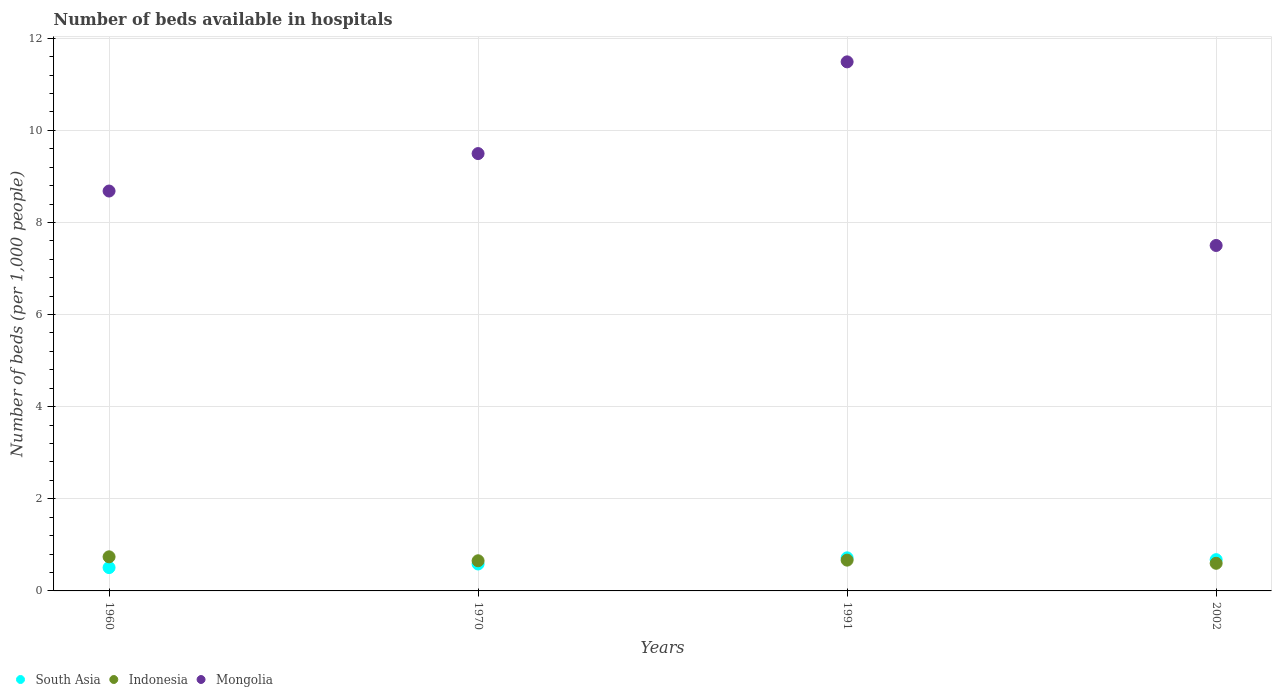How many different coloured dotlines are there?
Provide a short and direct response. 3. Is the number of dotlines equal to the number of legend labels?
Your answer should be compact. Yes. What is the number of beds in the hospiatls of in South Asia in 1970?
Make the answer very short. 0.58. Across all years, what is the maximum number of beds in the hospiatls of in South Asia?
Ensure brevity in your answer.  0.72. Across all years, what is the minimum number of beds in the hospiatls of in Indonesia?
Provide a succinct answer. 0.6. In which year was the number of beds in the hospiatls of in South Asia minimum?
Provide a short and direct response. 1960. What is the total number of beds in the hospiatls of in Mongolia in the graph?
Your response must be concise. 37.16. What is the difference between the number of beds in the hospiatls of in South Asia in 1960 and that in 1991?
Keep it short and to the point. -0.21. What is the difference between the number of beds in the hospiatls of in South Asia in 1991 and the number of beds in the hospiatls of in Mongolia in 1970?
Ensure brevity in your answer.  -8.78. What is the average number of beds in the hospiatls of in Mongolia per year?
Your response must be concise. 9.29. In the year 1970, what is the difference between the number of beds in the hospiatls of in Mongolia and number of beds in the hospiatls of in South Asia?
Keep it short and to the point. 8.91. In how many years, is the number of beds in the hospiatls of in Mongolia greater than 6?
Provide a short and direct response. 4. What is the ratio of the number of beds in the hospiatls of in Mongolia in 1960 to that in 2002?
Provide a succinct answer. 1.16. Is the number of beds in the hospiatls of in Indonesia in 1970 less than that in 1991?
Your answer should be compact. Yes. What is the difference between the highest and the second highest number of beds in the hospiatls of in Indonesia?
Provide a short and direct response. 0.07. What is the difference between the highest and the lowest number of beds in the hospiatls of in Mongolia?
Provide a short and direct response. 3.99. Is the sum of the number of beds in the hospiatls of in Mongolia in 1970 and 1991 greater than the maximum number of beds in the hospiatls of in Indonesia across all years?
Give a very brief answer. Yes. How many dotlines are there?
Offer a very short reply. 3. How many years are there in the graph?
Give a very brief answer. 4. Are the values on the major ticks of Y-axis written in scientific E-notation?
Offer a terse response. No. Does the graph contain any zero values?
Make the answer very short. No. Does the graph contain grids?
Keep it short and to the point. Yes. Where does the legend appear in the graph?
Your answer should be very brief. Bottom left. How many legend labels are there?
Your answer should be compact. 3. How are the legend labels stacked?
Ensure brevity in your answer.  Horizontal. What is the title of the graph?
Provide a succinct answer. Number of beds available in hospitals. Does "Cameroon" appear as one of the legend labels in the graph?
Give a very brief answer. No. What is the label or title of the Y-axis?
Keep it short and to the point. Number of beds (per 1,0 people). What is the Number of beds (per 1,000 people) in South Asia in 1960?
Offer a very short reply. 0.51. What is the Number of beds (per 1,000 people) in Indonesia in 1960?
Offer a very short reply. 0.74. What is the Number of beds (per 1,000 people) of Mongolia in 1960?
Give a very brief answer. 8.68. What is the Number of beds (per 1,000 people) in South Asia in 1970?
Your response must be concise. 0.58. What is the Number of beds (per 1,000 people) of Indonesia in 1970?
Your answer should be very brief. 0.65. What is the Number of beds (per 1,000 people) of Mongolia in 1970?
Your answer should be compact. 9.5. What is the Number of beds (per 1,000 people) of South Asia in 1991?
Make the answer very short. 0.72. What is the Number of beds (per 1,000 people) of Indonesia in 1991?
Provide a succinct answer. 0.67. What is the Number of beds (per 1,000 people) in Mongolia in 1991?
Provide a short and direct response. 11.49. What is the Number of beds (per 1,000 people) of South Asia in 2002?
Your answer should be compact. 0.68. Across all years, what is the maximum Number of beds (per 1,000 people) in South Asia?
Your response must be concise. 0.72. Across all years, what is the maximum Number of beds (per 1,000 people) of Indonesia?
Offer a terse response. 0.74. Across all years, what is the maximum Number of beds (per 1,000 people) of Mongolia?
Your answer should be compact. 11.49. Across all years, what is the minimum Number of beds (per 1,000 people) of South Asia?
Offer a very short reply. 0.51. What is the total Number of beds (per 1,000 people) in South Asia in the graph?
Ensure brevity in your answer.  2.49. What is the total Number of beds (per 1,000 people) in Indonesia in the graph?
Give a very brief answer. 2.66. What is the total Number of beds (per 1,000 people) of Mongolia in the graph?
Ensure brevity in your answer.  37.16. What is the difference between the Number of beds (per 1,000 people) in South Asia in 1960 and that in 1970?
Provide a short and direct response. -0.08. What is the difference between the Number of beds (per 1,000 people) of Indonesia in 1960 and that in 1970?
Give a very brief answer. 0.09. What is the difference between the Number of beds (per 1,000 people) in Mongolia in 1960 and that in 1970?
Keep it short and to the point. -0.81. What is the difference between the Number of beds (per 1,000 people) in South Asia in 1960 and that in 1991?
Give a very brief answer. -0.21. What is the difference between the Number of beds (per 1,000 people) in Indonesia in 1960 and that in 1991?
Your response must be concise. 0.07. What is the difference between the Number of beds (per 1,000 people) of Mongolia in 1960 and that in 1991?
Offer a terse response. -2.8. What is the difference between the Number of beds (per 1,000 people) in South Asia in 1960 and that in 2002?
Make the answer very short. -0.17. What is the difference between the Number of beds (per 1,000 people) in Indonesia in 1960 and that in 2002?
Offer a terse response. 0.14. What is the difference between the Number of beds (per 1,000 people) in Mongolia in 1960 and that in 2002?
Provide a short and direct response. 1.18. What is the difference between the Number of beds (per 1,000 people) of South Asia in 1970 and that in 1991?
Your answer should be very brief. -0.13. What is the difference between the Number of beds (per 1,000 people) of Indonesia in 1970 and that in 1991?
Provide a succinct answer. -0.01. What is the difference between the Number of beds (per 1,000 people) in Mongolia in 1970 and that in 1991?
Offer a terse response. -1.99. What is the difference between the Number of beds (per 1,000 people) in South Asia in 1970 and that in 2002?
Make the answer very short. -0.09. What is the difference between the Number of beds (per 1,000 people) of Indonesia in 1970 and that in 2002?
Make the answer very short. 0.05. What is the difference between the Number of beds (per 1,000 people) in Mongolia in 1970 and that in 2002?
Provide a short and direct response. 2. What is the difference between the Number of beds (per 1,000 people) in South Asia in 1991 and that in 2002?
Provide a short and direct response. 0.04. What is the difference between the Number of beds (per 1,000 people) in Indonesia in 1991 and that in 2002?
Make the answer very short. 0.07. What is the difference between the Number of beds (per 1,000 people) in Mongolia in 1991 and that in 2002?
Ensure brevity in your answer.  3.99. What is the difference between the Number of beds (per 1,000 people) in South Asia in 1960 and the Number of beds (per 1,000 people) in Indonesia in 1970?
Provide a short and direct response. -0.15. What is the difference between the Number of beds (per 1,000 people) in South Asia in 1960 and the Number of beds (per 1,000 people) in Mongolia in 1970?
Ensure brevity in your answer.  -8.99. What is the difference between the Number of beds (per 1,000 people) in Indonesia in 1960 and the Number of beds (per 1,000 people) in Mongolia in 1970?
Your answer should be compact. -8.75. What is the difference between the Number of beds (per 1,000 people) in South Asia in 1960 and the Number of beds (per 1,000 people) in Indonesia in 1991?
Your answer should be very brief. -0.16. What is the difference between the Number of beds (per 1,000 people) of South Asia in 1960 and the Number of beds (per 1,000 people) of Mongolia in 1991?
Offer a very short reply. -10.98. What is the difference between the Number of beds (per 1,000 people) in Indonesia in 1960 and the Number of beds (per 1,000 people) in Mongolia in 1991?
Ensure brevity in your answer.  -10.75. What is the difference between the Number of beds (per 1,000 people) in South Asia in 1960 and the Number of beds (per 1,000 people) in Indonesia in 2002?
Ensure brevity in your answer.  -0.09. What is the difference between the Number of beds (per 1,000 people) of South Asia in 1960 and the Number of beds (per 1,000 people) of Mongolia in 2002?
Give a very brief answer. -6.99. What is the difference between the Number of beds (per 1,000 people) in Indonesia in 1960 and the Number of beds (per 1,000 people) in Mongolia in 2002?
Make the answer very short. -6.76. What is the difference between the Number of beds (per 1,000 people) of South Asia in 1970 and the Number of beds (per 1,000 people) of Indonesia in 1991?
Give a very brief answer. -0.08. What is the difference between the Number of beds (per 1,000 people) in South Asia in 1970 and the Number of beds (per 1,000 people) in Mongolia in 1991?
Offer a very short reply. -10.9. What is the difference between the Number of beds (per 1,000 people) in Indonesia in 1970 and the Number of beds (per 1,000 people) in Mongolia in 1991?
Make the answer very short. -10.83. What is the difference between the Number of beds (per 1,000 people) of South Asia in 1970 and the Number of beds (per 1,000 people) of Indonesia in 2002?
Your answer should be very brief. -0.02. What is the difference between the Number of beds (per 1,000 people) in South Asia in 1970 and the Number of beds (per 1,000 people) in Mongolia in 2002?
Your response must be concise. -6.92. What is the difference between the Number of beds (per 1,000 people) of Indonesia in 1970 and the Number of beds (per 1,000 people) of Mongolia in 2002?
Your answer should be very brief. -6.85. What is the difference between the Number of beds (per 1,000 people) in South Asia in 1991 and the Number of beds (per 1,000 people) in Indonesia in 2002?
Offer a terse response. 0.12. What is the difference between the Number of beds (per 1,000 people) of South Asia in 1991 and the Number of beds (per 1,000 people) of Mongolia in 2002?
Provide a succinct answer. -6.78. What is the difference between the Number of beds (per 1,000 people) of Indonesia in 1991 and the Number of beds (per 1,000 people) of Mongolia in 2002?
Ensure brevity in your answer.  -6.83. What is the average Number of beds (per 1,000 people) of South Asia per year?
Provide a short and direct response. 0.62. What is the average Number of beds (per 1,000 people) of Indonesia per year?
Make the answer very short. 0.67. What is the average Number of beds (per 1,000 people) of Mongolia per year?
Ensure brevity in your answer.  9.29. In the year 1960, what is the difference between the Number of beds (per 1,000 people) in South Asia and Number of beds (per 1,000 people) in Indonesia?
Offer a very short reply. -0.23. In the year 1960, what is the difference between the Number of beds (per 1,000 people) in South Asia and Number of beds (per 1,000 people) in Mongolia?
Offer a terse response. -8.18. In the year 1960, what is the difference between the Number of beds (per 1,000 people) of Indonesia and Number of beds (per 1,000 people) of Mongolia?
Offer a very short reply. -7.94. In the year 1970, what is the difference between the Number of beds (per 1,000 people) in South Asia and Number of beds (per 1,000 people) in Indonesia?
Provide a short and direct response. -0.07. In the year 1970, what is the difference between the Number of beds (per 1,000 people) of South Asia and Number of beds (per 1,000 people) of Mongolia?
Keep it short and to the point. -8.91. In the year 1970, what is the difference between the Number of beds (per 1,000 people) of Indonesia and Number of beds (per 1,000 people) of Mongolia?
Offer a terse response. -8.84. In the year 1991, what is the difference between the Number of beds (per 1,000 people) in South Asia and Number of beds (per 1,000 people) in Indonesia?
Offer a terse response. 0.05. In the year 1991, what is the difference between the Number of beds (per 1,000 people) in South Asia and Number of beds (per 1,000 people) in Mongolia?
Offer a very short reply. -10.77. In the year 1991, what is the difference between the Number of beds (per 1,000 people) in Indonesia and Number of beds (per 1,000 people) in Mongolia?
Your answer should be compact. -10.82. In the year 2002, what is the difference between the Number of beds (per 1,000 people) of South Asia and Number of beds (per 1,000 people) of Indonesia?
Your answer should be compact. 0.08. In the year 2002, what is the difference between the Number of beds (per 1,000 people) in South Asia and Number of beds (per 1,000 people) in Mongolia?
Make the answer very short. -6.82. What is the ratio of the Number of beds (per 1,000 people) in South Asia in 1960 to that in 1970?
Provide a short and direct response. 0.87. What is the ratio of the Number of beds (per 1,000 people) in Indonesia in 1960 to that in 1970?
Provide a succinct answer. 1.13. What is the ratio of the Number of beds (per 1,000 people) of Mongolia in 1960 to that in 1970?
Your answer should be compact. 0.91. What is the ratio of the Number of beds (per 1,000 people) in South Asia in 1960 to that in 1991?
Offer a very short reply. 0.71. What is the ratio of the Number of beds (per 1,000 people) of Indonesia in 1960 to that in 1991?
Provide a short and direct response. 1.11. What is the ratio of the Number of beds (per 1,000 people) of Mongolia in 1960 to that in 1991?
Your answer should be very brief. 0.76. What is the ratio of the Number of beds (per 1,000 people) in South Asia in 1960 to that in 2002?
Make the answer very short. 0.75. What is the ratio of the Number of beds (per 1,000 people) of Indonesia in 1960 to that in 2002?
Provide a short and direct response. 1.23. What is the ratio of the Number of beds (per 1,000 people) of Mongolia in 1960 to that in 2002?
Offer a terse response. 1.16. What is the ratio of the Number of beds (per 1,000 people) of South Asia in 1970 to that in 1991?
Give a very brief answer. 0.81. What is the ratio of the Number of beds (per 1,000 people) in Indonesia in 1970 to that in 1991?
Provide a succinct answer. 0.98. What is the ratio of the Number of beds (per 1,000 people) of Mongolia in 1970 to that in 1991?
Your answer should be compact. 0.83. What is the ratio of the Number of beds (per 1,000 people) in South Asia in 1970 to that in 2002?
Give a very brief answer. 0.86. What is the ratio of the Number of beds (per 1,000 people) in Indonesia in 1970 to that in 2002?
Provide a succinct answer. 1.09. What is the ratio of the Number of beds (per 1,000 people) of Mongolia in 1970 to that in 2002?
Offer a terse response. 1.27. What is the ratio of the Number of beds (per 1,000 people) in South Asia in 1991 to that in 2002?
Offer a very short reply. 1.06. What is the ratio of the Number of beds (per 1,000 people) in Indonesia in 1991 to that in 2002?
Provide a short and direct response. 1.11. What is the ratio of the Number of beds (per 1,000 people) in Mongolia in 1991 to that in 2002?
Offer a very short reply. 1.53. What is the difference between the highest and the second highest Number of beds (per 1,000 people) of South Asia?
Keep it short and to the point. 0.04. What is the difference between the highest and the second highest Number of beds (per 1,000 people) of Indonesia?
Your answer should be compact. 0.07. What is the difference between the highest and the second highest Number of beds (per 1,000 people) of Mongolia?
Offer a terse response. 1.99. What is the difference between the highest and the lowest Number of beds (per 1,000 people) in South Asia?
Ensure brevity in your answer.  0.21. What is the difference between the highest and the lowest Number of beds (per 1,000 people) in Indonesia?
Ensure brevity in your answer.  0.14. What is the difference between the highest and the lowest Number of beds (per 1,000 people) in Mongolia?
Your answer should be very brief. 3.99. 